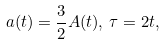Convert formula to latex. <formula><loc_0><loc_0><loc_500><loc_500>a ( t ) = \frac { 3 } { 2 } A ( t ) , \, \tau = 2 t ,</formula> 